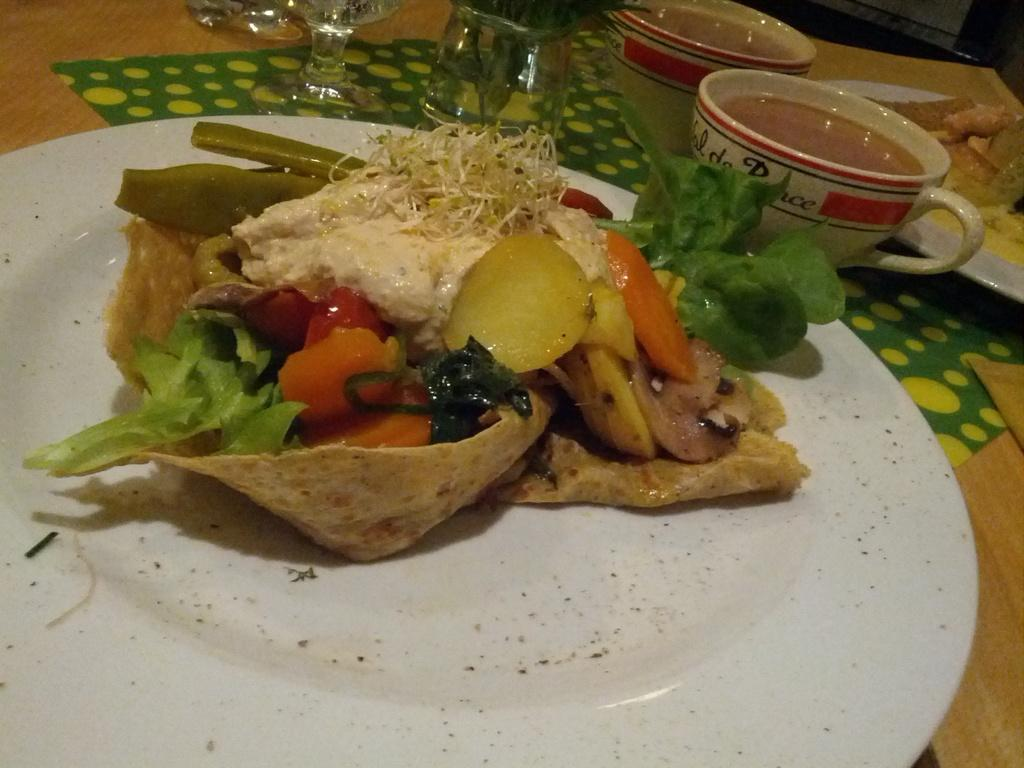What piece of furniture is present in the image? There is a table in the image. What items are placed on the table? There are plates, cups, glasses, and dishes on the table. Can you describe the tableware in the image? The tableware includes plates, cups, and glasses. What type of polish is being applied to the dishes in the image? There is no indication in the image that any polish is being applied to the dishes. 